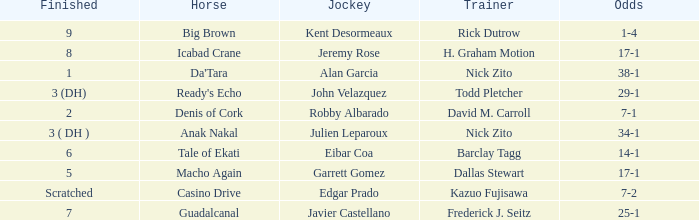What is the Finished place for da'tara trained by Nick zito? 1.0. 